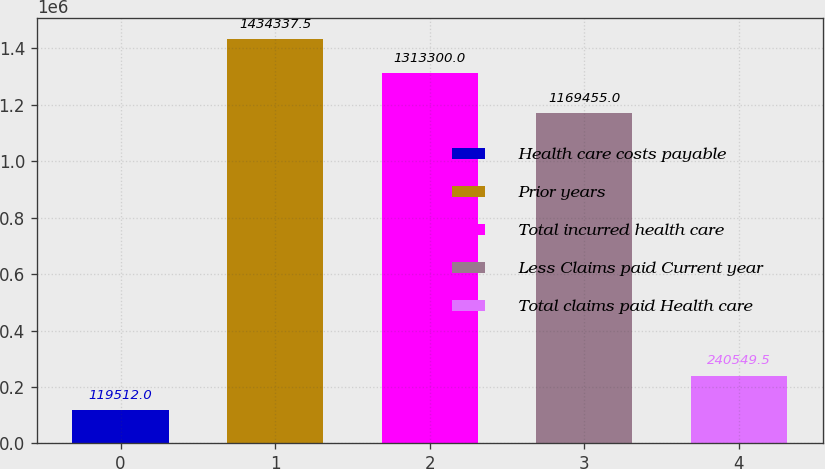Convert chart. <chart><loc_0><loc_0><loc_500><loc_500><bar_chart><fcel>Health care costs payable<fcel>Prior years<fcel>Total incurred health care<fcel>Less Claims paid Current year<fcel>Total claims paid Health care<nl><fcel>119512<fcel>1.43434e+06<fcel>1.3133e+06<fcel>1.16946e+06<fcel>240550<nl></chart> 